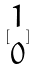Convert formula to latex. <formula><loc_0><loc_0><loc_500><loc_500>[ \begin{matrix} 1 \\ 0 \end{matrix} ]</formula> 